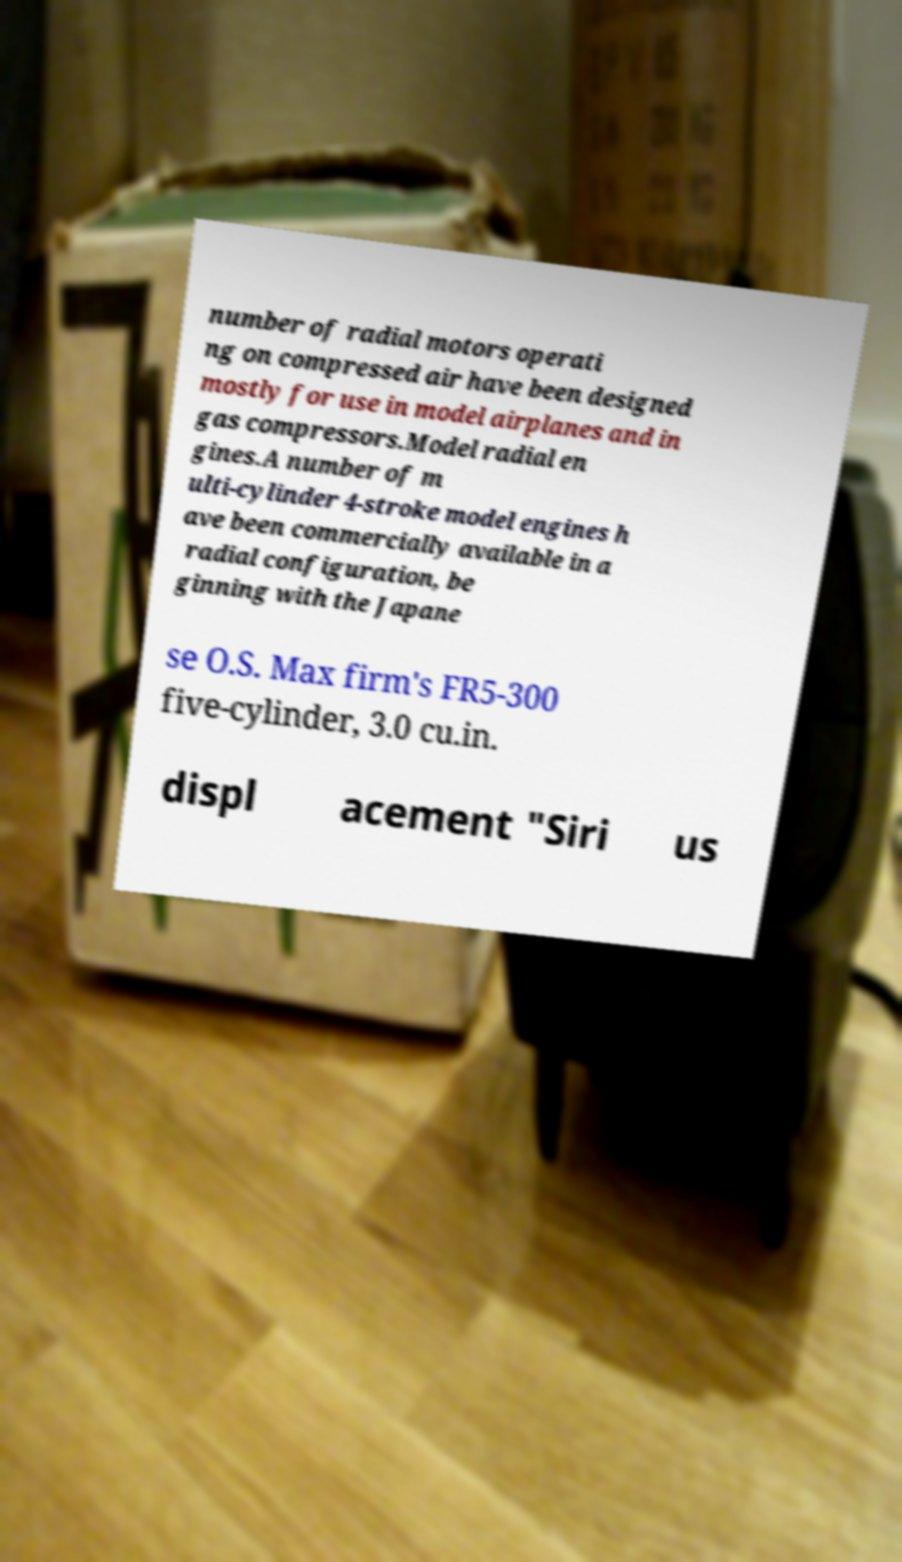What messages or text are displayed in this image? I need them in a readable, typed format. number of radial motors operati ng on compressed air have been designed mostly for use in model airplanes and in gas compressors.Model radial en gines.A number of m ulti-cylinder 4-stroke model engines h ave been commercially available in a radial configuration, be ginning with the Japane se O.S. Max firm's FR5-300 five-cylinder, 3.0 cu.in. displ acement "Siri us 